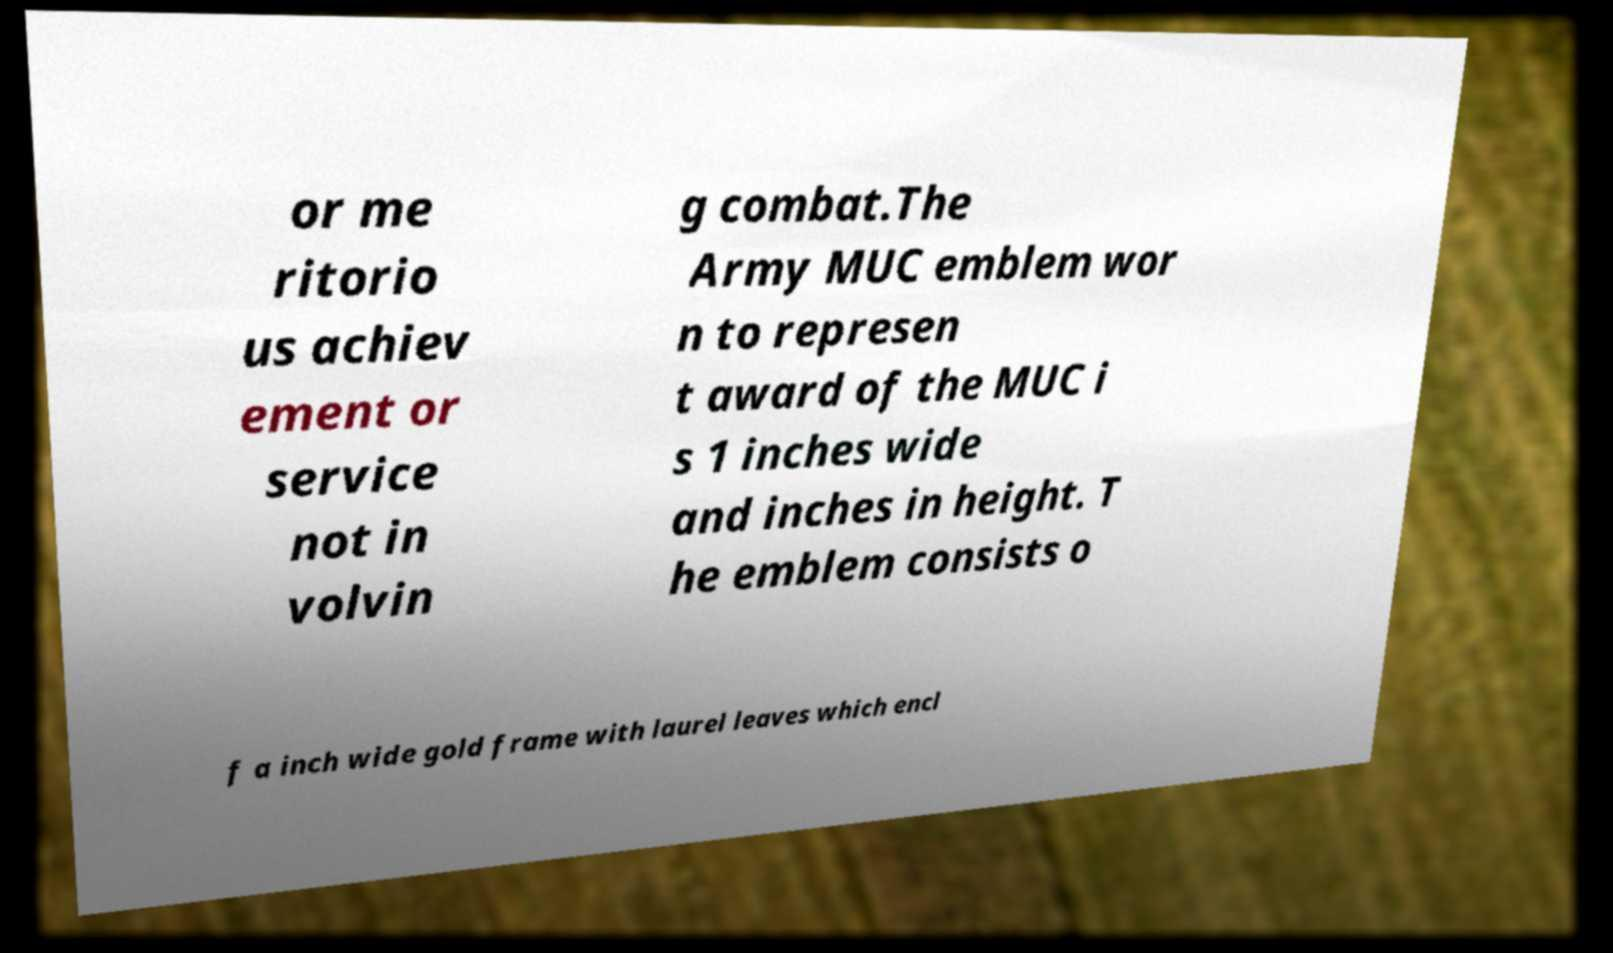I need the written content from this picture converted into text. Can you do that? or me ritorio us achiev ement or service not in volvin g combat.The Army MUC emblem wor n to represen t award of the MUC i s 1 inches wide and inches in height. T he emblem consists o f a inch wide gold frame with laurel leaves which encl 